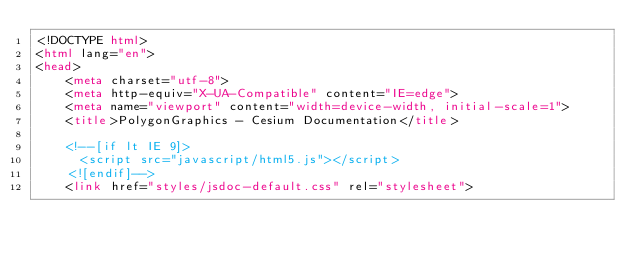Convert code to text. <code><loc_0><loc_0><loc_500><loc_500><_HTML_><!DOCTYPE html>
<html lang="en">
<head>
    <meta charset="utf-8">
    <meta http-equiv="X-UA-Compatible" content="IE=edge">
    <meta name="viewport" content="width=device-width, initial-scale=1">
    <title>PolygonGraphics - Cesium Documentation</title>

    <!--[if lt IE 9]>
      <script src="javascript/html5.js"></script>
    <![endif]-->
    <link href="styles/jsdoc-default.css" rel="stylesheet"></code> 